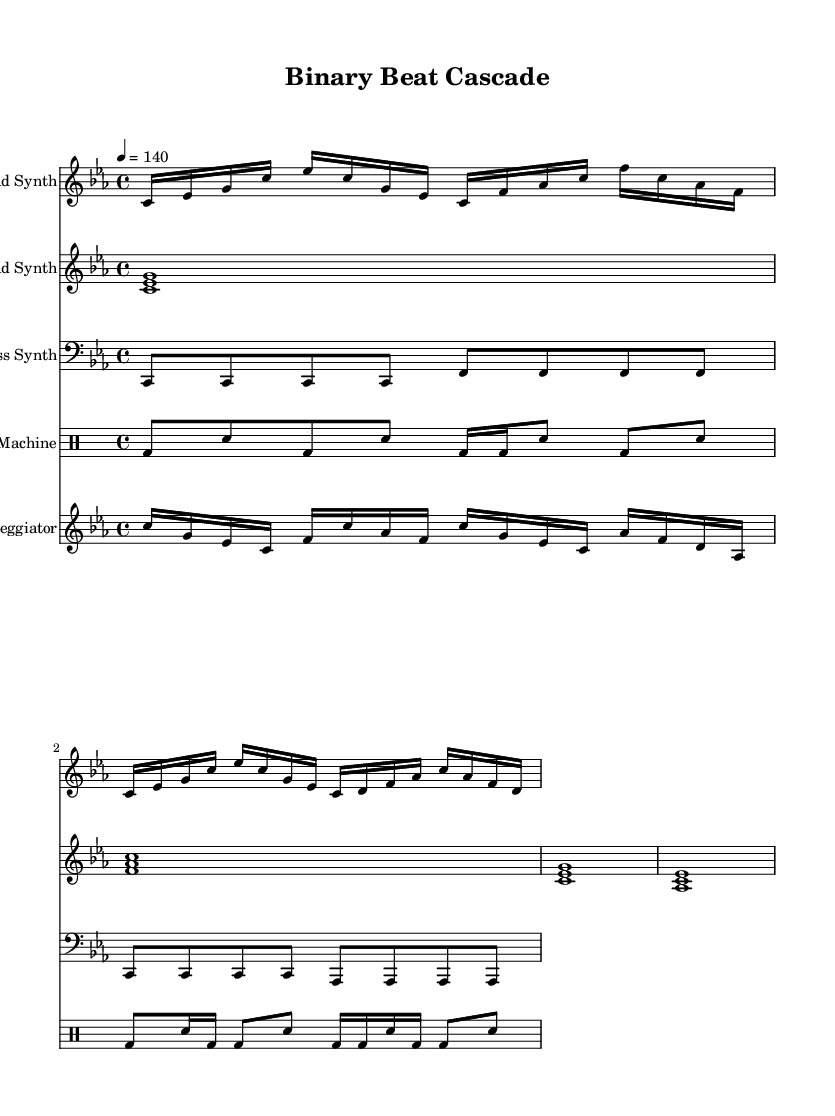What is the key signature of this music? The key signature is identified at the beginning of the score. This particular piece is in C minor, which has three flats: B flat, E flat, and A flat.
Answer: C minor What is the time signature of this music? The time signature is located next to the key signature. In this score, it is indicated as 4/4, which means there are four beats per measure and the quarter note gets one beat.
Answer: 4/4 What is the tempo marking of the piece? The tempo marking appears at the start of the score, where it is set to 4 equals 140. This indicates the number of beats per minute and the basic unit used for pacing.
Answer: 140 How many distinct synthesizer parts are presented in the score? By examining the score, we can count the number of musician parts listed: Lead Synth, Pad Synth, Bass Synth, and Arpeggiator. This totals four distinct synthesizer parts along with a separate drum machine.
Answer: Four What rhythmic pattern is prominent in the drum machine part? The drum machine section shows a repetitive pattern of bass drum and snare hits. Specifically, the bass drum appears on the downbeats, with alternating snare hits creating a driving rhythm, typical of techno.
Answer: Alternating bass and snare What type of musical structure is primarily used in this dance track? The structure can be inferred from the rhythmic and melodic patterns repeating throughout the score. The presence of defined sections and repetitiveness suggests a loop-based structure, common in dance music, sustaining energy over time.
Answer: Loop-based What is the highest pitch used by the lead synth? The lead synth part is laid out in the score and follows a specific melodic contour. The highest note reached in this part is B flat, located in measure three of the sequence.
Answer: B flat 